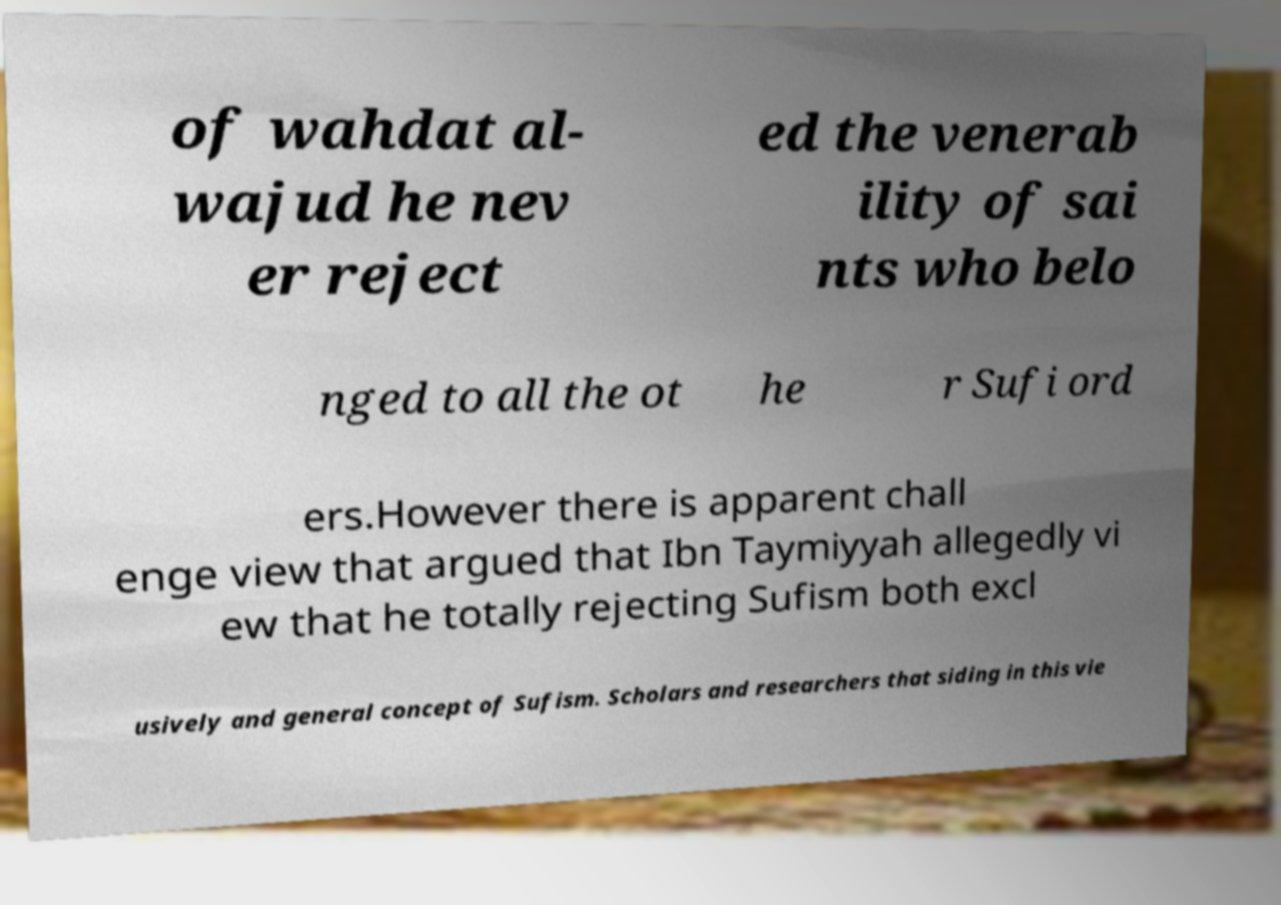What messages or text are displayed in this image? I need them in a readable, typed format. of wahdat al- wajud he nev er reject ed the venerab ility of sai nts who belo nged to all the ot he r Sufi ord ers.However there is apparent chall enge view that argued that Ibn Taymiyyah allegedly vi ew that he totally rejecting Sufism both excl usively and general concept of Sufism. Scholars and researchers that siding in this vie 